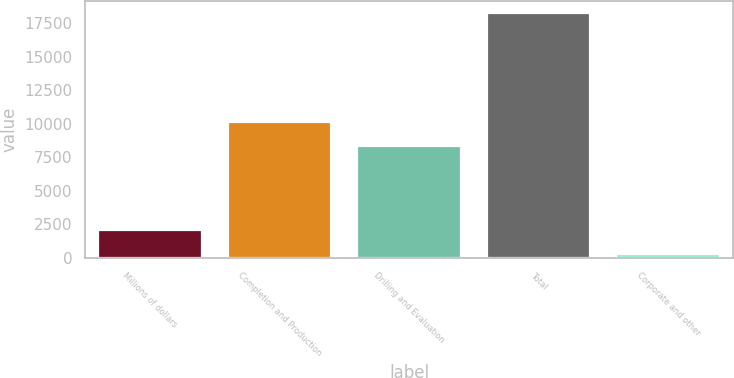Convert chart. <chart><loc_0><loc_0><loc_500><loc_500><bar_chart><fcel>Millions of dollars<fcel>Completion and Production<fcel>Drilling and Evaluation<fcel>Total<fcel>Corporate and other<nl><fcel>2065.5<fcel>10145.5<fcel>8344<fcel>18279<fcel>264<nl></chart> 